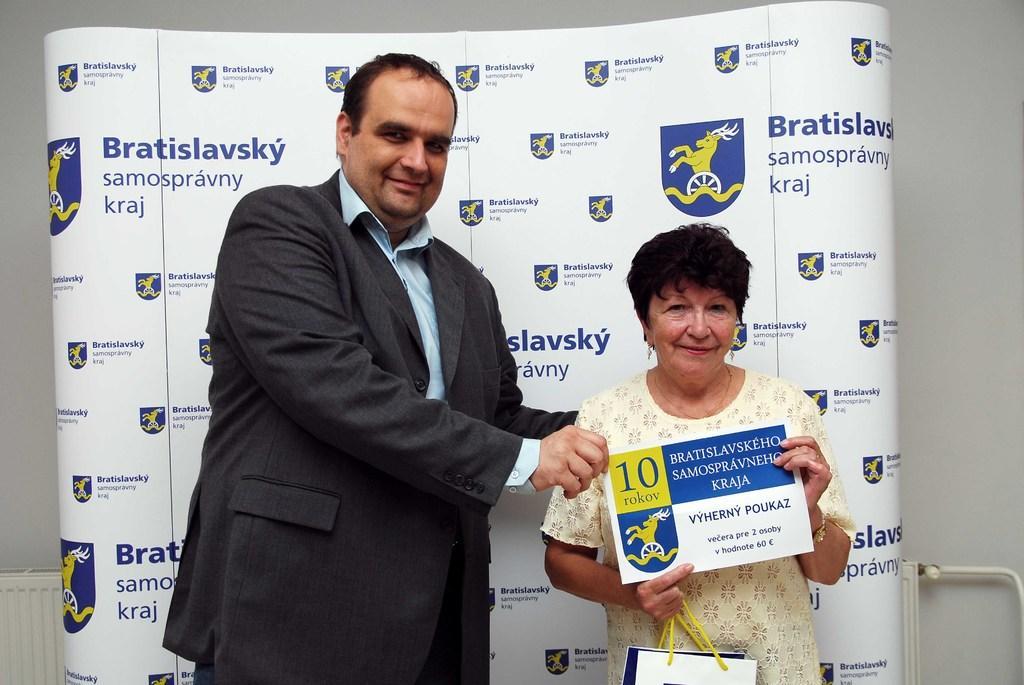Describe this image in one or two sentences. There are two people standing and holding a poster and this woman holding a bag,behind these two people we can see banner. In the background we can see wall. 